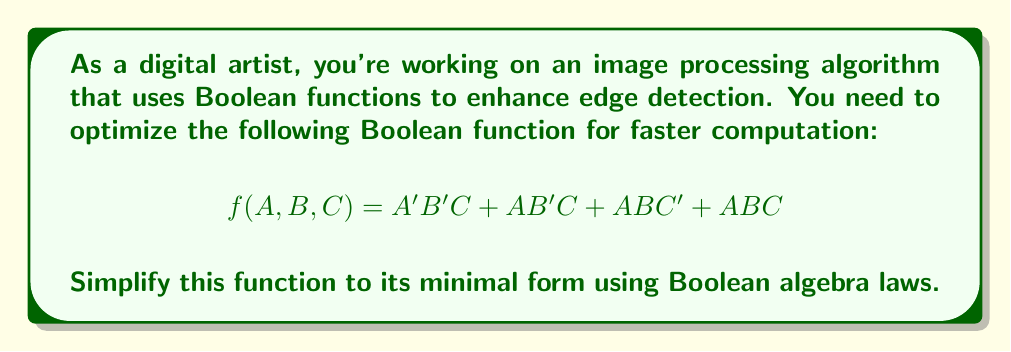Can you solve this math problem? Let's simplify this Boolean function step by step:

1) First, we can use the distributive law to factor out common terms:
   $f(A, B, C) = B'C(A' + A) + AB(C' + C)$

2) Using the complementary law, we know that $(A' + A) = 1$ and $(C' + C) = 1$:
   $f(A, B, C) = B'C(1) + AB(1)$

3) Simplify:
   $f(A, B, C) = B'C + AB$

4) We can't simplify this further, as there are no common terms left.

This simplified form reduces the number of operations needed to compute the function, which is crucial for efficient image processing. The original function required 7 operations (3 ANDs, 3 ORs, and 1 NOT), while the simplified version only needs 3 operations (2 ANDs and 1 OR).
Answer: $f(A, B, C) = B'C + AB$ 